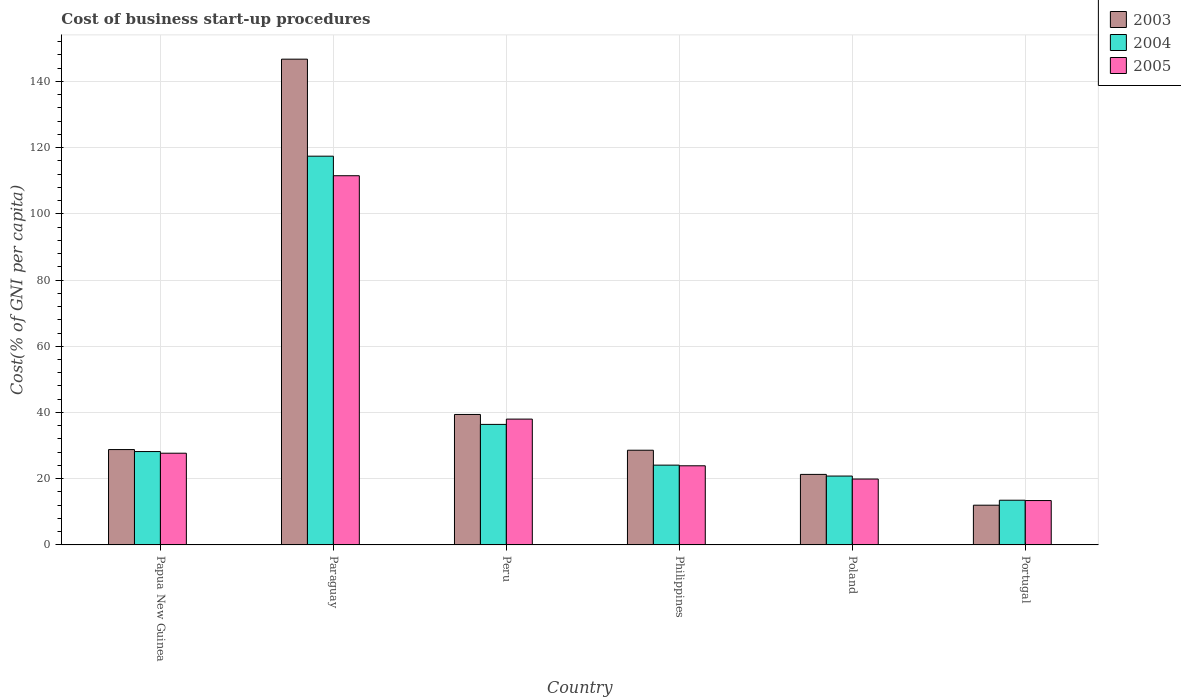How many groups of bars are there?
Offer a terse response. 6. How many bars are there on the 2nd tick from the left?
Provide a succinct answer. 3. What is the cost of business start-up procedures in 2004 in Peru?
Keep it short and to the point. 36.4. Across all countries, what is the maximum cost of business start-up procedures in 2004?
Provide a succinct answer. 117.4. In which country was the cost of business start-up procedures in 2005 maximum?
Provide a succinct answer. Paraguay. In which country was the cost of business start-up procedures in 2003 minimum?
Keep it short and to the point. Portugal. What is the total cost of business start-up procedures in 2003 in the graph?
Your response must be concise. 276.8. What is the difference between the cost of business start-up procedures in 2005 in Papua New Guinea and that in Poland?
Ensure brevity in your answer.  7.8. What is the difference between the cost of business start-up procedures in 2005 in Poland and the cost of business start-up procedures in 2003 in Portugal?
Your answer should be compact. 7.9. What is the average cost of business start-up procedures in 2004 per country?
Your answer should be compact. 40.07. What is the difference between the cost of business start-up procedures of/in 2004 and cost of business start-up procedures of/in 2005 in Philippines?
Ensure brevity in your answer.  0.2. What is the ratio of the cost of business start-up procedures in 2004 in Paraguay to that in Philippines?
Provide a succinct answer. 4.87. What is the difference between the highest and the lowest cost of business start-up procedures in 2003?
Ensure brevity in your answer.  134.7. What does the 2nd bar from the right in Peru represents?
Your answer should be very brief. 2004. Is it the case that in every country, the sum of the cost of business start-up procedures in 2004 and cost of business start-up procedures in 2005 is greater than the cost of business start-up procedures in 2003?
Give a very brief answer. Yes. How many bars are there?
Provide a short and direct response. 18. Are all the bars in the graph horizontal?
Offer a very short reply. No. What is the difference between two consecutive major ticks on the Y-axis?
Your response must be concise. 20. Are the values on the major ticks of Y-axis written in scientific E-notation?
Offer a terse response. No. Does the graph contain any zero values?
Give a very brief answer. No. How many legend labels are there?
Your answer should be compact. 3. How are the legend labels stacked?
Provide a succinct answer. Vertical. What is the title of the graph?
Provide a short and direct response. Cost of business start-up procedures. Does "2011" appear as one of the legend labels in the graph?
Make the answer very short. No. What is the label or title of the Y-axis?
Keep it short and to the point. Cost(% of GNI per capita). What is the Cost(% of GNI per capita) of 2003 in Papua New Guinea?
Offer a terse response. 28.8. What is the Cost(% of GNI per capita) of 2004 in Papua New Guinea?
Your answer should be compact. 28.2. What is the Cost(% of GNI per capita) of 2005 in Papua New Guinea?
Offer a very short reply. 27.7. What is the Cost(% of GNI per capita) of 2003 in Paraguay?
Make the answer very short. 146.7. What is the Cost(% of GNI per capita) in 2004 in Paraguay?
Give a very brief answer. 117.4. What is the Cost(% of GNI per capita) in 2005 in Paraguay?
Provide a short and direct response. 111.5. What is the Cost(% of GNI per capita) of 2003 in Peru?
Offer a very short reply. 39.4. What is the Cost(% of GNI per capita) of 2004 in Peru?
Ensure brevity in your answer.  36.4. What is the Cost(% of GNI per capita) of 2003 in Philippines?
Keep it short and to the point. 28.6. What is the Cost(% of GNI per capita) of 2004 in Philippines?
Give a very brief answer. 24.1. What is the Cost(% of GNI per capita) of 2005 in Philippines?
Provide a succinct answer. 23.9. What is the Cost(% of GNI per capita) of 2003 in Poland?
Ensure brevity in your answer.  21.3. What is the Cost(% of GNI per capita) in 2004 in Poland?
Your answer should be very brief. 20.8. What is the Cost(% of GNI per capita) in 2005 in Poland?
Make the answer very short. 19.9. What is the Cost(% of GNI per capita) of 2003 in Portugal?
Make the answer very short. 12. Across all countries, what is the maximum Cost(% of GNI per capita) in 2003?
Keep it short and to the point. 146.7. Across all countries, what is the maximum Cost(% of GNI per capita) of 2004?
Offer a terse response. 117.4. Across all countries, what is the maximum Cost(% of GNI per capita) in 2005?
Provide a short and direct response. 111.5. Across all countries, what is the minimum Cost(% of GNI per capita) in 2003?
Your answer should be compact. 12. Across all countries, what is the minimum Cost(% of GNI per capita) of 2004?
Provide a short and direct response. 13.5. What is the total Cost(% of GNI per capita) in 2003 in the graph?
Keep it short and to the point. 276.8. What is the total Cost(% of GNI per capita) in 2004 in the graph?
Offer a terse response. 240.4. What is the total Cost(% of GNI per capita) in 2005 in the graph?
Offer a terse response. 234.4. What is the difference between the Cost(% of GNI per capita) of 2003 in Papua New Guinea and that in Paraguay?
Keep it short and to the point. -117.9. What is the difference between the Cost(% of GNI per capita) of 2004 in Papua New Guinea and that in Paraguay?
Your answer should be compact. -89.2. What is the difference between the Cost(% of GNI per capita) of 2005 in Papua New Guinea and that in Paraguay?
Ensure brevity in your answer.  -83.8. What is the difference between the Cost(% of GNI per capita) of 2003 in Papua New Guinea and that in Peru?
Ensure brevity in your answer.  -10.6. What is the difference between the Cost(% of GNI per capita) in 2004 in Papua New Guinea and that in Peru?
Offer a terse response. -8.2. What is the difference between the Cost(% of GNI per capita) in 2003 in Papua New Guinea and that in Philippines?
Your answer should be compact. 0.2. What is the difference between the Cost(% of GNI per capita) in 2003 in Papua New Guinea and that in Poland?
Provide a short and direct response. 7.5. What is the difference between the Cost(% of GNI per capita) of 2004 in Papua New Guinea and that in Poland?
Ensure brevity in your answer.  7.4. What is the difference between the Cost(% of GNI per capita) of 2005 in Papua New Guinea and that in Portugal?
Offer a very short reply. 14.3. What is the difference between the Cost(% of GNI per capita) in 2003 in Paraguay and that in Peru?
Provide a short and direct response. 107.3. What is the difference between the Cost(% of GNI per capita) of 2004 in Paraguay and that in Peru?
Keep it short and to the point. 81. What is the difference between the Cost(% of GNI per capita) of 2005 in Paraguay and that in Peru?
Your answer should be very brief. 73.5. What is the difference between the Cost(% of GNI per capita) of 2003 in Paraguay and that in Philippines?
Offer a terse response. 118.1. What is the difference between the Cost(% of GNI per capita) of 2004 in Paraguay and that in Philippines?
Ensure brevity in your answer.  93.3. What is the difference between the Cost(% of GNI per capita) of 2005 in Paraguay and that in Philippines?
Your answer should be compact. 87.6. What is the difference between the Cost(% of GNI per capita) of 2003 in Paraguay and that in Poland?
Provide a succinct answer. 125.4. What is the difference between the Cost(% of GNI per capita) of 2004 in Paraguay and that in Poland?
Provide a short and direct response. 96.6. What is the difference between the Cost(% of GNI per capita) in 2005 in Paraguay and that in Poland?
Provide a succinct answer. 91.6. What is the difference between the Cost(% of GNI per capita) of 2003 in Paraguay and that in Portugal?
Your answer should be very brief. 134.7. What is the difference between the Cost(% of GNI per capita) in 2004 in Paraguay and that in Portugal?
Your response must be concise. 103.9. What is the difference between the Cost(% of GNI per capita) of 2005 in Paraguay and that in Portugal?
Your answer should be very brief. 98.1. What is the difference between the Cost(% of GNI per capita) of 2004 in Peru and that in Philippines?
Offer a very short reply. 12.3. What is the difference between the Cost(% of GNI per capita) in 2003 in Peru and that in Portugal?
Your answer should be very brief. 27.4. What is the difference between the Cost(% of GNI per capita) of 2004 in Peru and that in Portugal?
Offer a very short reply. 22.9. What is the difference between the Cost(% of GNI per capita) in 2005 in Peru and that in Portugal?
Offer a very short reply. 24.6. What is the difference between the Cost(% of GNI per capita) in 2004 in Philippines and that in Poland?
Offer a terse response. 3.3. What is the difference between the Cost(% of GNI per capita) in 2003 in Philippines and that in Portugal?
Keep it short and to the point. 16.6. What is the difference between the Cost(% of GNI per capita) in 2004 in Philippines and that in Portugal?
Give a very brief answer. 10.6. What is the difference between the Cost(% of GNI per capita) of 2005 in Philippines and that in Portugal?
Make the answer very short. 10.5. What is the difference between the Cost(% of GNI per capita) of 2003 in Poland and that in Portugal?
Ensure brevity in your answer.  9.3. What is the difference between the Cost(% of GNI per capita) in 2004 in Poland and that in Portugal?
Give a very brief answer. 7.3. What is the difference between the Cost(% of GNI per capita) in 2005 in Poland and that in Portugal?
Keep it short and to the point. 6.5. What is the difference between the Cost(% of GNI per capita) in 2003 in Papua New Guinea and the Cost(% of GNI per capita) in 2004 in Paraguay?
Offer a very short reply. -88.6. What is the difference between the Cost(% of GNI per capita) in 2003 in Papua New Guinea and the Cost(% of GNI per capita) in 2005 in Paraguay?
Keep it short and to the point. -82.7. What is the difference between the Cost(% of GNI per capita) in 2004 in Papua New Guinea and the Cost(% of GNI per capita) in 2005 in Paraguay?
Give a very brief answer. -83.3. What is the difference between the Cost(% of GNI per capita) of 2003 in Papua New Guinea and the Cost(% of GNI per capita) of 2004 in Philippines?
Provide a short and direct response. 4.7. What is the difference between the Cost(% of GNI per capita) of 2003 in Papua New Guinea and the Cost(% of GNI per capita) of 2005 in Philippines?
Offer a very short reply. 4.9. What is the difference between the Cost(% of GNI per capita) in 2004 in Papua New Guinea and the Cost(% of GNI per capita) in 2005 in Philippines?
Ensure brevity in your answer.  4.3. What is the difference between the Cost(% of GNI per capita) of 2003 in Papua New Guinea and the Cost(% of GNI per capita) of 2004 in Poland?
Ensure brevity in your answer.  8. What is the difference between the Cost(% of GNI per capita) of 2004 in Papua New Guinea and the Cost(% of GNI per capita) of 2005 in Portugal?
Give a very brief answer. 14.8. What is the difference between the Cost(% of GNI per capita) in 2003 in Paraguay and the Cost(% of GNI per capita) in 2004 in Peru?
Give a very brief answer. 110.3. What is the difference between the Cost(% of GNI per capita) of 2003 in Paraguay and the Cost(% of GNI per capita) of 2005 in Peru?
Keep it short and to the point. 108.7. What is the difference between the Cost(% of GNI per capita) in 2004 in Paraguay and the Cost(% of GNI per capita) in 2005 in Peru?
Ensure brevity in your answer.  79.4. What is the difference between the Cost(% of GNI per capita) of 2003 in Paraguay and the Cost(% of GNI per capita) of 2004 in Philippines?
Your answer should be very brief. 122.6. What is the difference between the Cost(% of GNI per capita) in 2003 in Paraguay and the Cost(% of GNI per capita) in 2005 in Philippines?
Your response must be concise. 122.8. What is the difference between the Cost(% of GNI per capita) in 2004 in Paraguay and the Cost(% of GNI per capita) in 2005 in Philippines?
Your response must be concise. 93.5. What is the difference between the Cost(% of GNI per capita) in 2003 in Paraguay and the Cost(% of GNI per capita) in 2004 in Poland?
Give a very brief answer. 125.9. What is the difference between the Cost(% of GNI per capita) of 2003 in Paraguay and the Cost(% of GNI per capita) of 2005 in Poland?
Ensure brevity in your answer.  126.8. What is the difference between the Cost(% of GNI per capita) in 2004 in Paraguay and the Cost(% of GNI per capita) in 2005 in Poland?
Your response must be concise. 97.5. What is the difference between the Cost(% of GNI per capita) of 2003 in Paraguay and the Cost(% of GNI per capita) of 2004 in Portugal?
Give a very brief answer. 133.2. What is the difference between the Cost(% of GNI per capita) of 2003 in Paraguay and the Cost(% of GNI per capita) of 2005 in Portugal?
Ensure brevity in your answer.  133.3. What is the difference between the Cost(% of GNI per capita) in 2004 in Paraguay and the Cost(% of GNI per capita) in 2005 in Portugal?
Ensure brevity in your answer.  104. What is the difference between the Cost(% of GNI per capita) in 2003 in Peru and the Cost(% of GNI per capita) in 2004 in Philippines?
Your response must be concise. 15.3. What is the difference between the Cost(% of GNI per capita) of 2004 in Peru and the Cost(% of GNI per capita) of 2005 in Poland?
Your response must be concise. 16.5. What is the difference between the Cost(% of GNI per capita) of 2003 in Peru and the Cost(% of GNI per capita) of 2004 in Portugal?
Your response must be concise. 25.9. What is the difference between the Cost(% of GNI per capita) in 2003 in Peru and the Cost(% of GNI per capita) in 2005 in Portugal?
Your answer should be very brief. 26. What is the difference between the Cost(% of GNI per capita) in 2004 in Peru and the Cost(% of GNI per capita) in 2005 in Portugal?
Your response must be concise. 23. What is the difference between the Cost(% of GNI per capita) in 2003 in Philippines and the Cost(% of GNI per capita) in 2004 in Portugal?
Provide a short and direct response. 15.1. What is the difference between the Cost(% of GNI per capita) in 2003 in Philippines and the Cost(% of GNI per capita) in 2005 in Portugal?
Ensure brevity in your answer.  15.2. What is the difference between the Cost(% of GNI per capita) in 2003 in Poland and the Cost(% of GNI per capita) in 2005 in Portugal?
Provide a succinct answer. 7.9. What is the difference between the Cost(% of GNI per capita) of 2004 in Poland and the Cost(% of GNI per capita) of 2005 in Portugal?
Give a very brief answer. 7.4. What is the average Cost(% of GNI per capita) in 2003 per country?
Provide a short and direct response. 46.13. What is the average Cost(% of GNI per capita) of 2004 per country?
Ensure brevity in your answer.  40.07. What is the average Cost(% of GNI per capita) of 2005 per country?
Keep it short and to the point. 39.07. What is the difference between the Cost(% of GNI per capita) of 2003 and Cost(% of GNI per capita) of 2004 in Papua New Guinea?
Your response must be concise. 0.6. What is the difference between the Cost(% of GNI per capita) in 2003 and Cost(% of GNI per capita) in 2005 in Papua New Guinea?
Give a very brief answer. 1.1. What is the difference between the Cost(% of GNI per capita) of 2004 and Cost(% of GNI per capita) of 2005 in Papua New Guinea?
Offer a terse response. 0.5. What is the difference between the Cost(% of GNI per capita) of 2003 and Cost(% of GNI per capita) of 2004 in Paraguay?
Your answer should be compact. 29.3. What is the difference between the Cost(% of GNI per capita) of 2003 and Cost(% of GNI per capita) of 2005 in Paraguay?
Give a very brief answer. 35.2. What is the difference between the Cost(% of GNI per capita) in 2004 and Cost(% of GNI per capita) in 2005 in Paraguay?
Keep it short and to the point. 5.9. What is the difference between the Cost(% of GNI per capita) of 2003 and Cost(% of GNI per capita) of 2004 in Peru?
Ensure brevity in your answer.  3. What is the difference between the Cost(% of GNI per capita) of 2003 and Cost(% of GNI per capita) of 2005 in Peru?
Give a very brief answer. 1.4. What is the difference between the Cost(% of GNI per capita) in 2004 and Cost(% of GNI per capita) in 2005 in Peru?
Offer a terse response. -1.6. What is the difference between the Cost(% of GNI per capita) in 2003 and Cost(% of GNI per capita) in 2004 in Philippines?
Your answer should be very brief. 4.5. What is the difference between the Cost(% of GNI per capita) in 2003 and Cost(% of GNI per capita) in 2004 in Portugal?
Provide a short and direct response. -1.5. What is the ratio of the Cost(% of GNI per capita) in 2003 in Papua New Guinea to that in Paraguay?
Provide a short and direct response. 0.2. What is the ratio of the Cost(% of GNI per capita) of 2004 in Papua New Guinea to that in Paraguay?
Keep it short and to the point. 0.24. What is the ratio of the Cost(% of GNI per capita) in 2005 in Papua New Guinea to that in Paraguay?
Provide a succinct answer. 0.25. What is the ratio of the Cost(% of GNI per capita) in 2003 in Papua New Guinea to that in Peru?
Provide a succinct answer. 0.73. What is the ratio of the Cost(% of GNI per capita) of 2004 in Papua New Guinea to that in Peru?
Give a very brief answer. 0.77. What is the ratio of the Cost(% of GNI per capita) in 2005 in Papua New Guinea to that in Peru?
Make the answer very short. 0.73. What is the ratio of the Cost(% of GNI per capita) in 2004 in Papua New Guinea to that in Philippines?
Your answer should be very brief. 1.17. What is the ratio of the Cost(% of GNI per capita) of 2005 in Papua New Guinea to that in Philippines?
Offer a very short reply. 1.16. What is the ratio of the Cost(% of GNI per capita) in 2003 in Papua New Guinea to that in Poland?
Your answer should be compact. 1.35. What is the ratio of the Cost(% of GNI per capita) in 2004 in Papua New Guinea to that in Poland?
Your answer should be very brief. 1.36. What is the ratio of the Cost(% of GNI per capita) in 2005 in Papua New Guinea to that in Poland?
Provide a succinct answer. 1.39. What is the ratio of the Cost(% of GNI per capita) of 2004 in Papua New Guinea to that in Portugal?
Give a very brief answer. 2.09. What is the ratio of the Cost(% of GNI per capita) in 2005 in Papua New Guinea to that in Portugal?
Your answer should be compact. 2.07. What is the ratio of the Cost(% of GNI per capita) of 2003 in Paraguay to that in Peru?
Provide a succinct answer. 3.72. What is the ratio of the Cost(% of GNI per capita) in 2004 in Paraguay to that in Peru?
Provide a short and direct response. 3.23. What is the ratio of the Cost(% of GNI per capita) of 2005 in Paraguay to that in Peru?
Your answer should be very brief. 2.93. What is the ratio of the Cost(% of GNI per capita) of 2003 in Paraguay to that in Philippines?
Offer a terse response. 5.13. What is the ratio of the Cost(% of GNI per capita) of 2004 in Paraguay to that in Philippines?
Offer a very short reply. 4.87. What is the ratio of the Cost(% of GNI per capita) in 2005 in Paraguay to that in Philippines?
Your response must be concise. 4.67. What is the ratio of the Cost(% of GNI per capita) of 2003 in Paraguay to that in Poland?
Provide a succinct answer. 6.89. What is the ratio of the Cost(% of GNI per capita) of 2004 in Paraguay to that in Poland?
Keep it short and to the point. 5.64. What is the ratio of the Cost(% of GNI per capita) of 2005 in Paraguay to that in Poland?
Your answer should be very brief. 5.6. What is the ratio of the Cost(% of GNI per capita) of 2003 in Paraguay to that in Portugal?
Make the answer very short. 12.22. What is the ratio of the Cost(% of GNI per capita) in 2004 in Paraguay to that in Portugal?
Ensure brevity in your answer.  8.7. What is the ratio of the Cost(% of GNI per capita) of 2005 in Paraguay to that in Portugal?
Your answer should be very brief. 8.32. What is the ratio of the Cost(% of GNI per capita) of 2003 in Peru to that in Philippines?
Your answer should be compact. 1.38. What is the ratio of the Cost(% of GNI per capita) of 2004 in Peru to that in Philippines?
Give a very brief answer. 1.51. What is the ratio of the Cost(% of GNI per capita) in 2005 in Peru to that in Philippines?
Your answer should be compact. 1.59. What is the ratio of the Cost(% of GNI per capita) in 2003 in Peru to that in Poland?
Give a very brief answer. 1.85. What is the ratio of the Cost(% of GNI per capita) in 2004 in Peru to that in Poland?
Provide a succinct answer. 1.75. What is the ratio of the Cost(% of GNI per capita) of 2005 in Peru to that in Poland?
Your answer should be very brief. 1.91. What is the ratio of the Cost(% of GNI per capita) in 2003 in Peru to that in Portugal?
Ensure brevity in your answer.  3.28. What is the ratio of the Cost(% of GNI per capita) in 2004 in Peru to that in Portugal?
Your answer should be very brief. 2.7. What is the ratio of the Cost(% of GNI per capita) in 2005 in Peru to that in Portugal?
Offer a very short reply. 2.84. What is the ratio of the Cost(% of GNI per capita) in 2003 in Philippines to that in Poland?
Your answer should be compact. 1.34. What is the ratio of the Cost(% of GNI per capita) of 2004 in Philippines to that in Poland?
Give a very brief answer. 1.16. What is the ratio of the Cost(% of GNI per capita) of 2005 in Philippines to that in Poland?
Give a very brief answer. 1.2. What is the ratio of the Cost(% of GNI per capita) of 2003 in Philippines to that in Portugal?
Ensure brevity in your answer.  2.38. What is the ratio of the Cost(% of GNI per capita) in 2004 in Philippines to that in Portugal?
Offer a terse response. 1.79. What is the ratio of the Cost(% of GNI per capita) in 2005 in Philippines to that in Portugal?
Your answer should be very brief. 1.78. What is the ratio of the Cost(% of GNI per capita) of 2003 in Poland to that in Portugal?
Offer a terse response. 1.77. What is the ratio of the Cost(% of GNI per capita) of 2004 in Poland to that in Portugal?
Your response must be concise. 1.54. What is the ratio of the Cost(% of GNI per capita) of 2005 in Poland to that in Portugal?
Provide a short and direct response. 1.49. What is the difference between the highest and the second highest Cost(% of GNI per capita) in 2003?
Keep it short and to the point. 107.3. What is the difference between the highest and the second highest Cost(% of GNI per capita) of 2005?
Ensure brevity in your answer.  73.5. What is the difference between the highest and the lowest Cost(% of GNI per capita) of 2003?
Keep it short and to the point. 134.7. What is the difference between the highest and the lowest Cost(% of GNI per capita) of 2004?
Your answer should be very brief. 103.9. What is the difference between the highest and the lowest Cost(% of GNI per capita) of 2005?
Your answer should be compact. 98.1. 